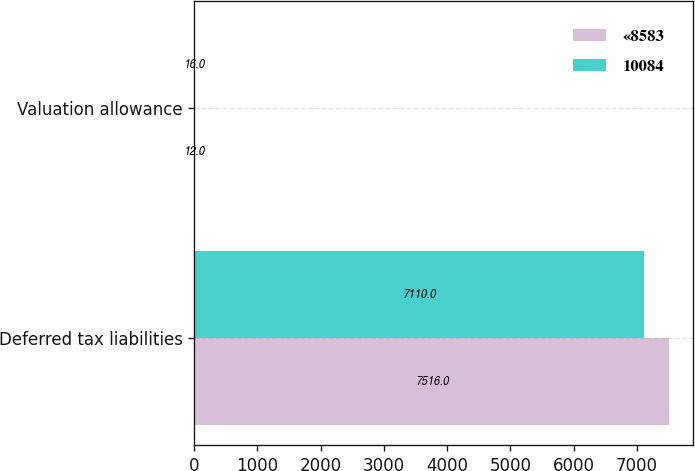Convert chart to OTSL. <chart><loc_0><loc_0><loc_500><loc_500><stacked_bar_chart><ecel><fcel>Deferred tax liabilities<fcel>Valuation allowance<nl><fcel>«8583<fcel>7516<fcel>12<nl><fcel>10084<fcel>7110<fcel>16<nl></chart> 